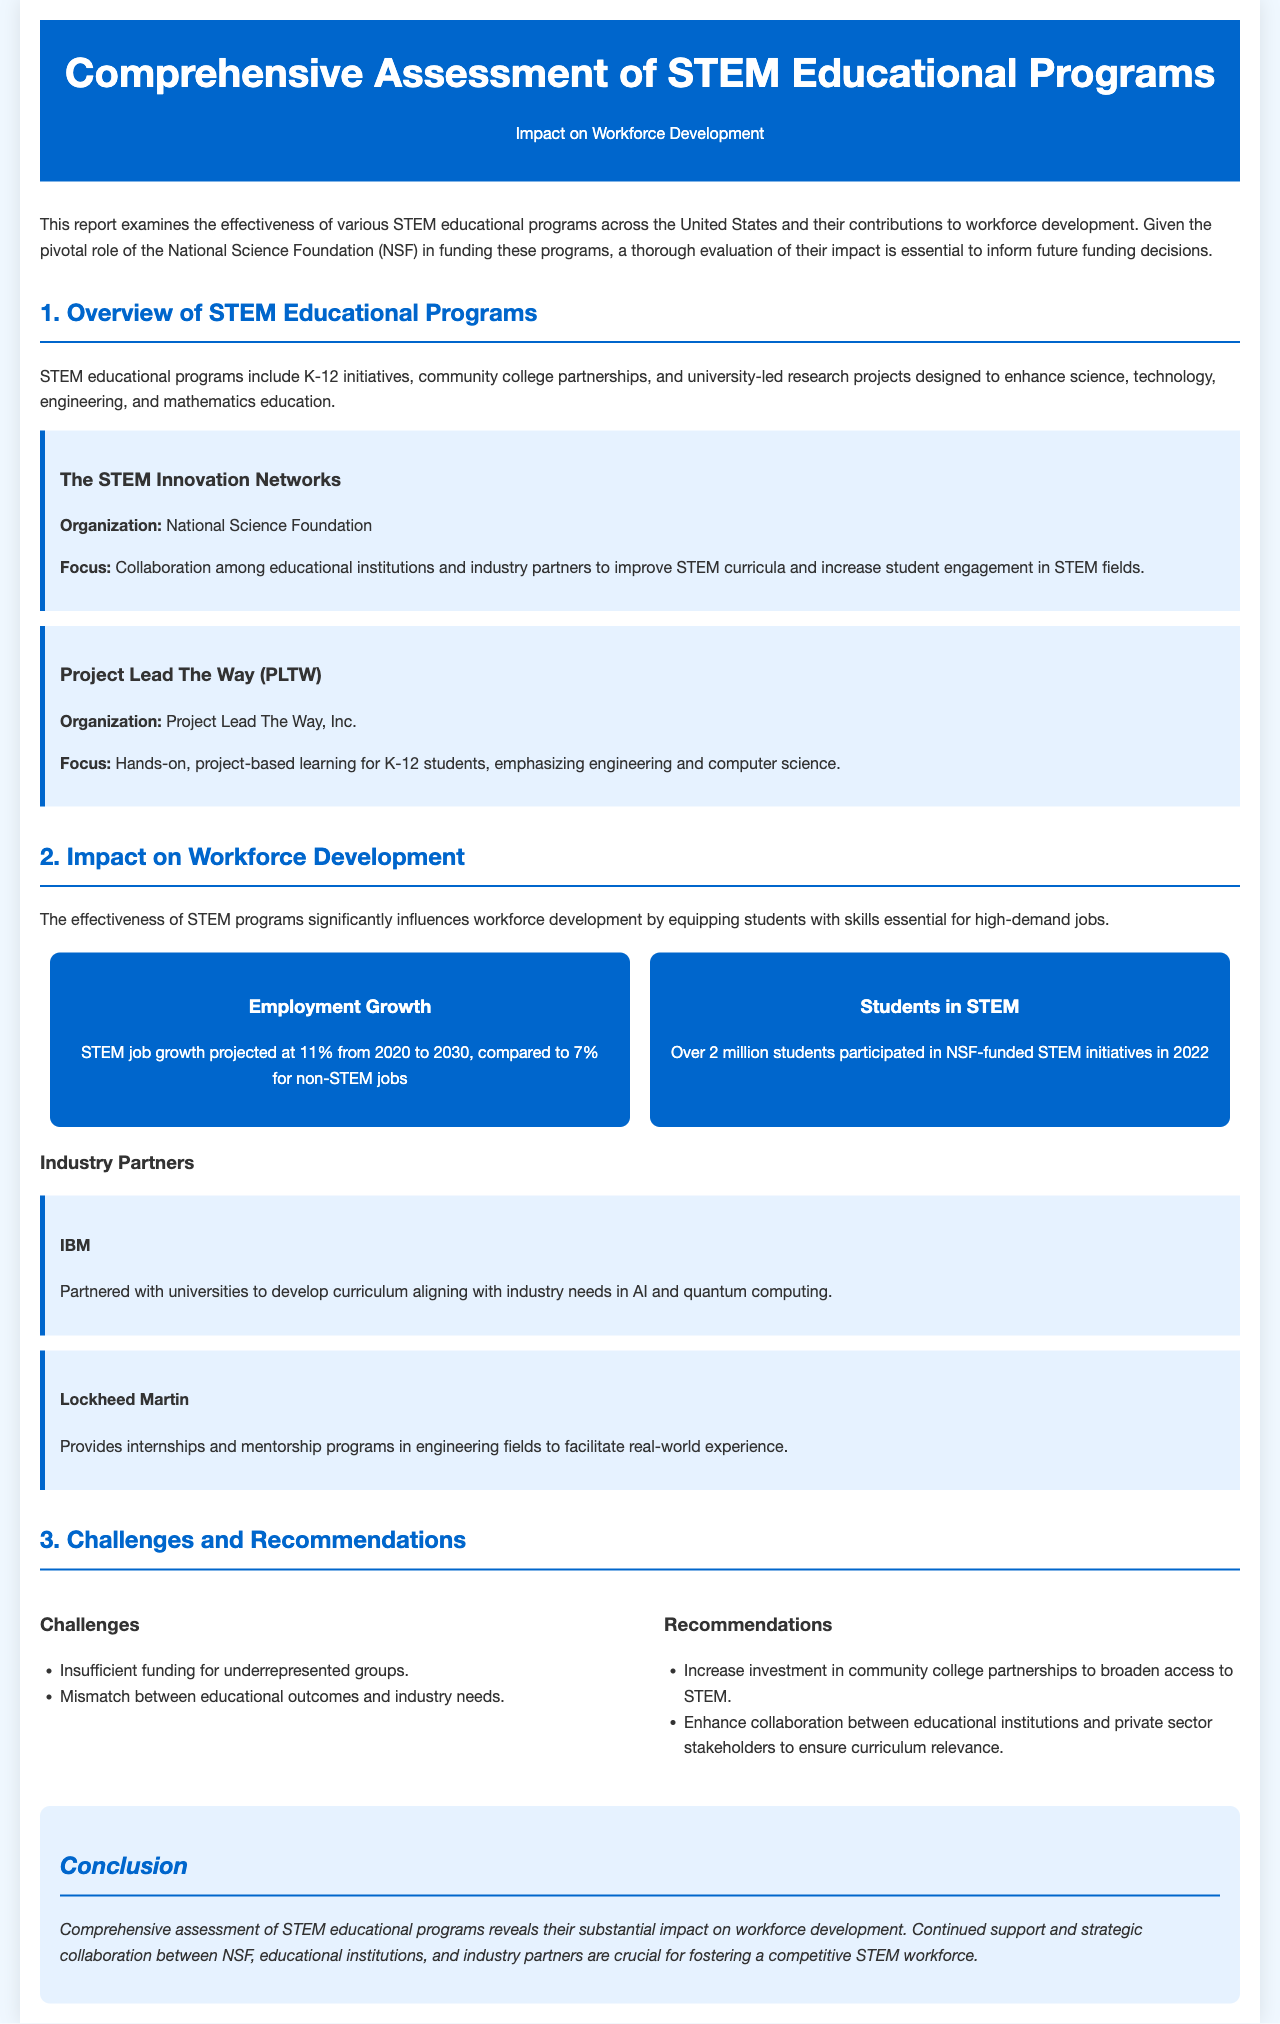what is the focus of Project Lead The Way? The focus of Project Lead The Way is hands-on, project-based learning for K-12 students, emphasizing engineering and computer science.
Answer: hands-on, project-based learning for K-12 students, emphasizing engineering and computer science how many students participated in NSF-funded STEM initiatives in 2022? The document states that over 2 million students participated in NSF-funded STEM initiatives in 2022.
Answer: over 2 million what is the projected STEM job growth percentage from 2020 to 2030? The projected STEM job growth is stated as 11% from 2020 to 2030 in the document.
Answer: 11% what challenges are faced by STEM educational programs? The document lists insufficient funding for underrepresented groups and a mismatch between educational outcomes and industry needs as challenges.
Answer: insufficient funding for underrepresented groups; mismatch between educational outcomes and industry needs which organization partnered with universities for curriculum development in AI? The organization that partnered with universities to develop curriculum aligning with industry needs in AI is IBM.
Answer: IBM what is the main conclusion of the report? The main conclusion states that comprehensive assessment of STEM educational programs reveals their substantial impact on workforce development.
Answer: substantial impact on workforce development who provided internships and mentorship programs in engineering fields? The document identifies Lockheed Martin as the organization that provides internships and mentorship programs in engineering fields.
Answer: Lockheed Martin what do the recommendations suggest to improve STEM education? The recommendations suggest increasing investment in community college partnerships and enhancing collaboration between educational institutions and private sector stakeholders.
Answer: increase investment in community college partnerships; enhance collaboration between educational institutions and private sector stakeholders 